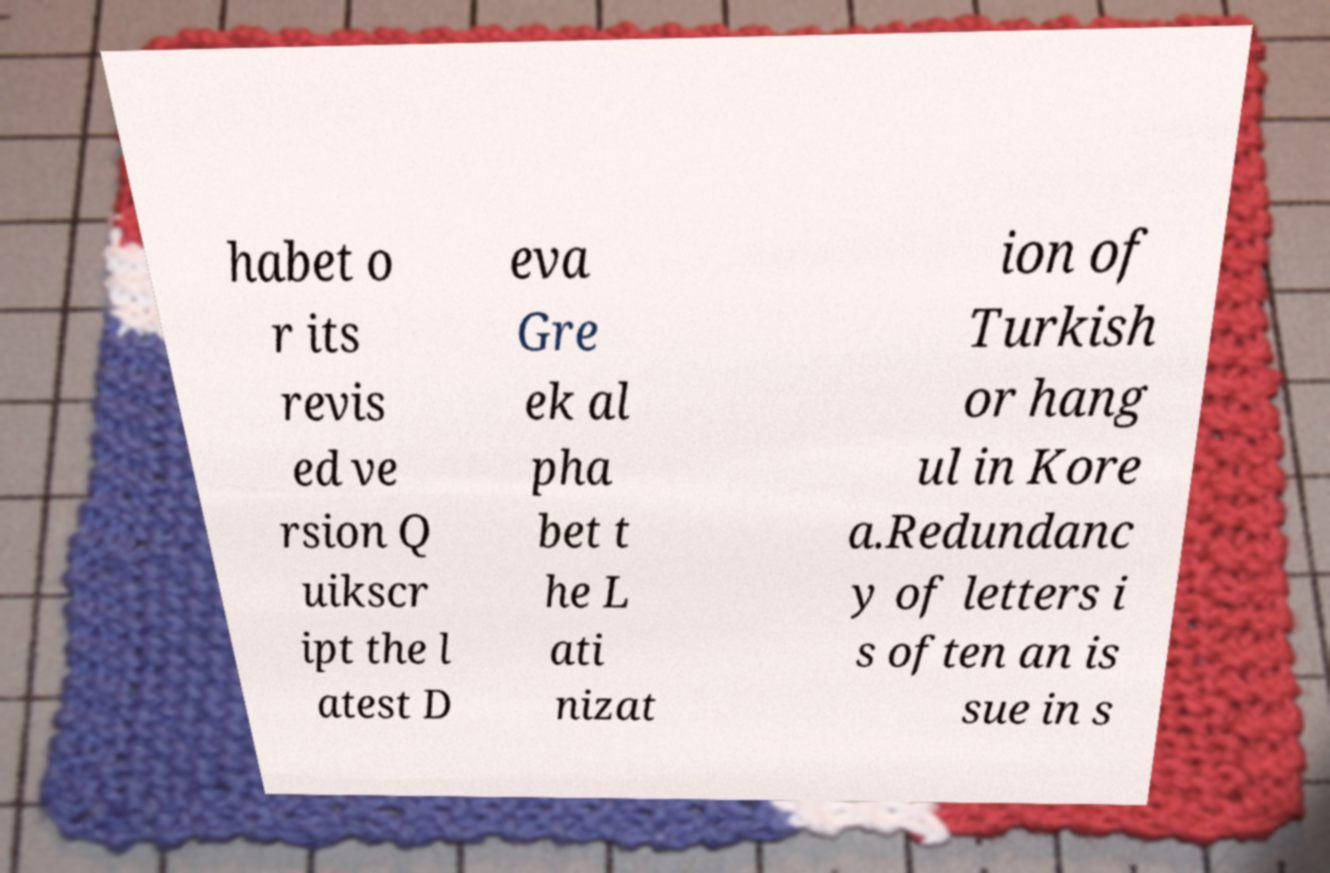Please identify and transcribe the text found in this image. habet o r its revis ed ve rsion Q uikscr ipt the l atest D eva Gre ek al pha bet t he L ati nizat ion of Turkish or hang ul in Kore a.Redundanc y of letters i s often an is sue in s 